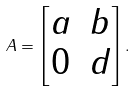<formula> <loc_0><loc_0><loc_500><loc_500>A = \begin{bmatrix} a & b \\ 0 & d \end{bmatrix} .</formula> 